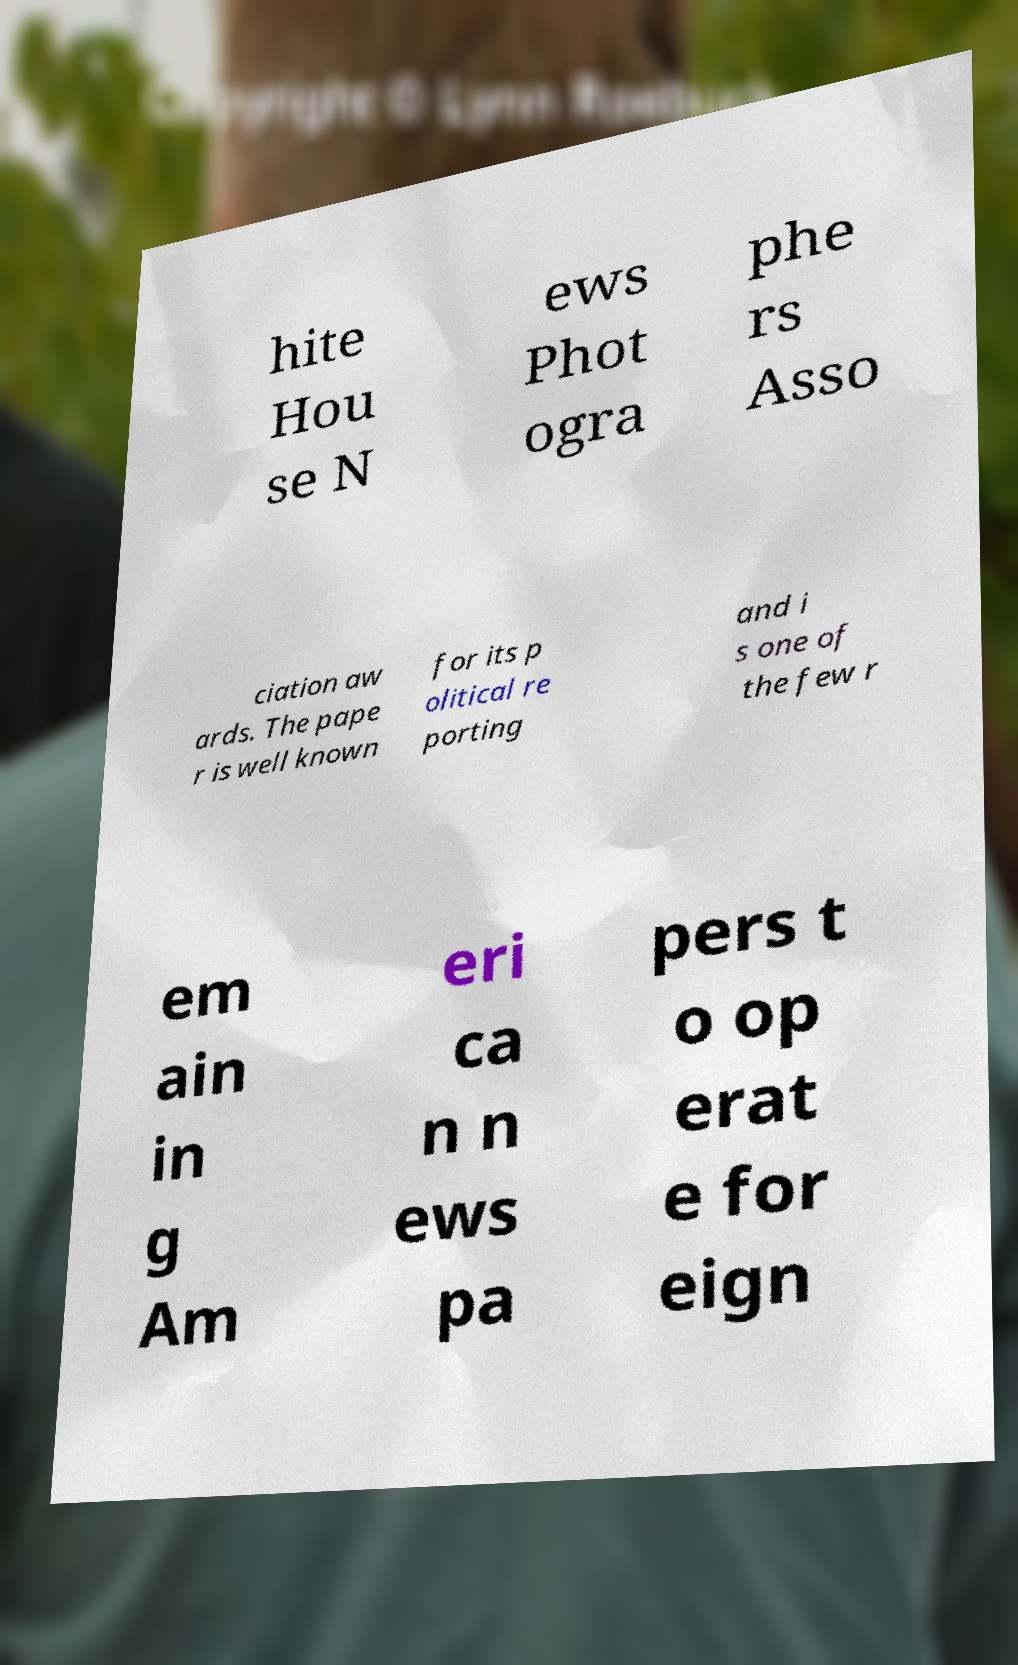Could you assist in decoding the text presented in this image and type it out clearly? hite Hou se N ews Phot ogra phe rs Asso ciation aw ards. The pape r is well known for its p olitical re porting and i s one of the few r em ain in g Am eri ca n n ews pa pers t o op erat e for eign 